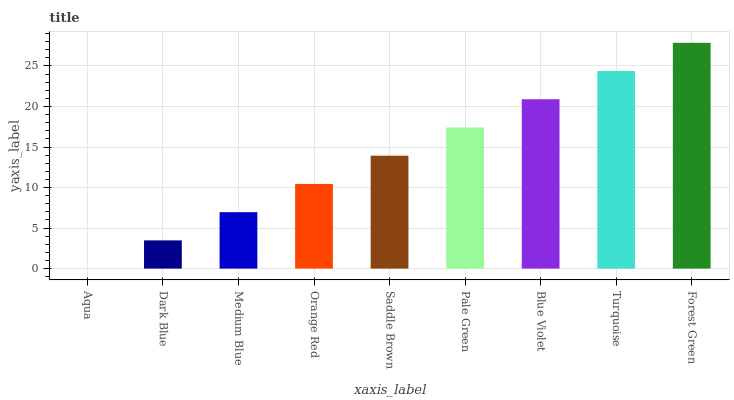Is Dark Blue the minimum?
Answer yes or no. No. Is Dark Blue the maximum?
Answer yes or no. No. Is Dark Blue greater than Aqua?
Answer yes or no. Yes. Is Aqua less than Dark Blue?
Answer yes or no. Yes. Is Aqua greater than Dark Blue?
Answer yes or no. No. Is Dark Blue less than Aqua?
Answer yes or no. No. Is Saddle Brown the high median?
Answer yes or no. Yes. Is Saddle Brown the low median?
Answer yes or no. Yes. Is Turquoise the high median?
Answer yes or no. No. Is Blue Violet the low median?
Answer yes or no. No. 